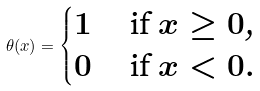<formula> <loc_0><loc_0><loc_500><loc_500>\theta ( x ) = \begin{cases} 1 & \text { if $x\geq 0$,} \\ 0 & \text { if $x < 0$.} \end{cases}</formula> 